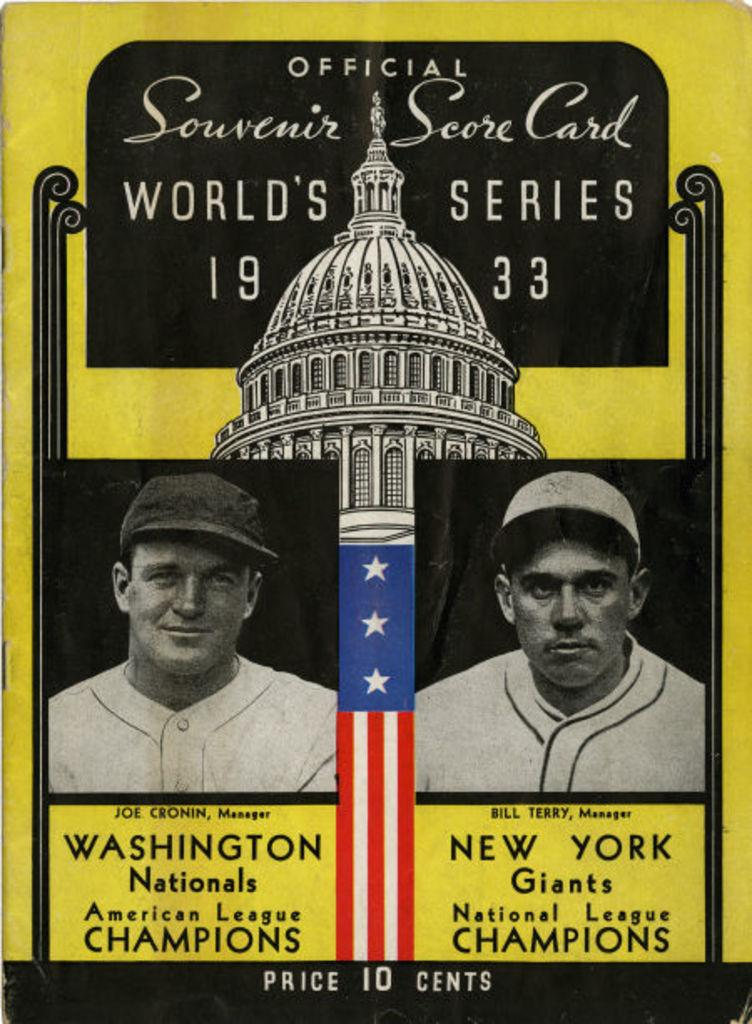What is featured in the image? There is a poster in the image. What can be seen on the poster? The poster contains two men wearing caps, a flag, a building, and text. What riddle is being solved by the visitor in the image? There is no visitor or riddle present in the image; it only features a poster with two men, a flag, a building, and text. 